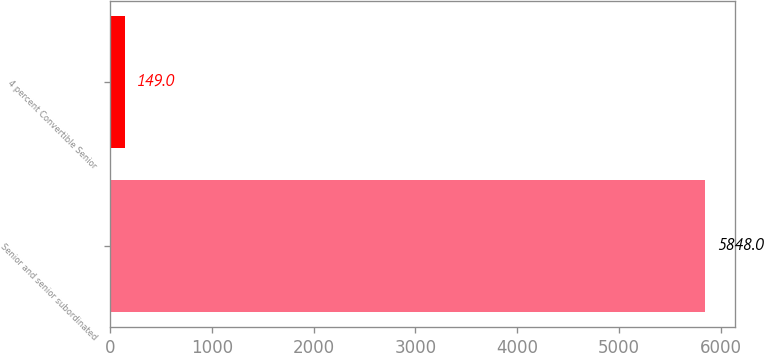Convert chart. <chart><loc_0><loc_0><loc_500><loc_500><bar_chart><fcel>Senior and senior subordinated<fcel>4 percent Convertible Senior<nl><fcel>5848<fcel>149<nl></chart> 